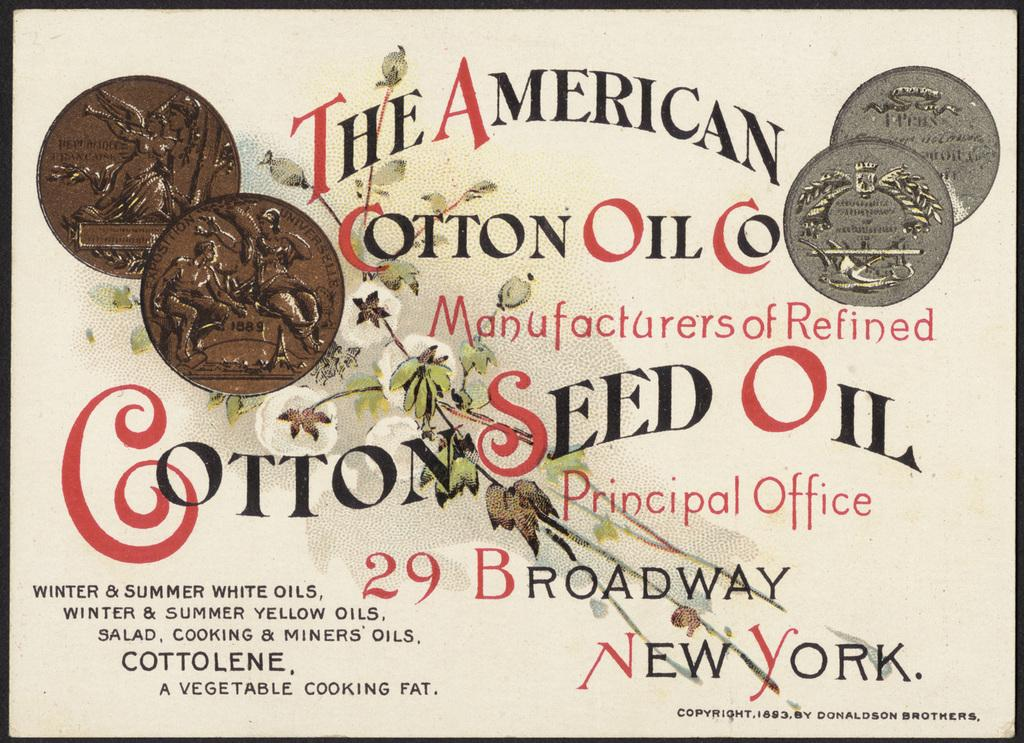<image>
Give a short and clear explanation of the subsequent image. a sign for The American Cotton Oil and Cotton Seed 